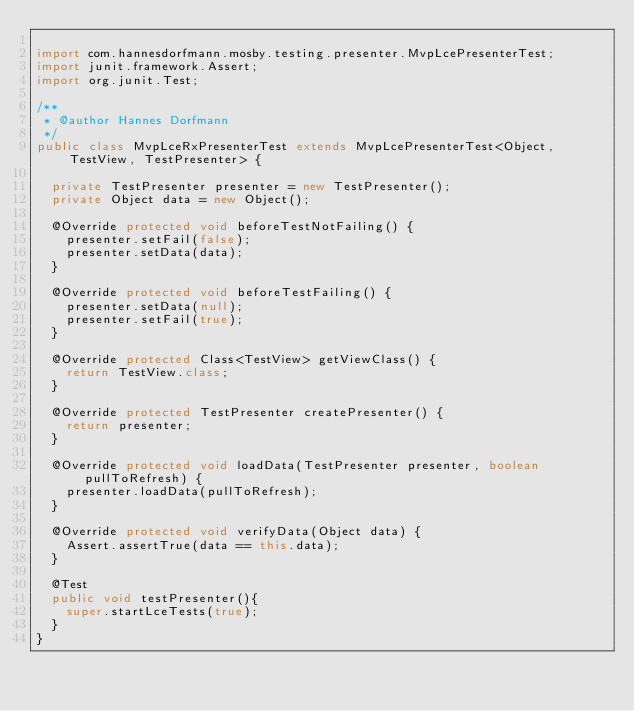<code> <loc_0><loc_0><loc_500><loc_500><_Java_>
import com.hannesdorfmann.mosby.testing.presenter.MvpLcePresenterTest;
import junit.framework.Assert;
import org.junit.Test;

/**
 * @author Hannes Dorfmann
 */
public class MvpLceRxPresenterTest extends MvpLcePresenterTest<Object, TestView, TestPresenter> {

  private TestPresenter presenter = new TestPresenter();
  private Object data = new Object();

  @Override protected void beforeTestNotFailing() {
    presenter.setFail(false);
    presenter.setData(data);
  }

  @Override protected void beforeTestFailing() {
    presenter.setData(null);
    presenter.setFail(true);
  }

  @Override protected Class<TestView> getViewClass() {
    return TestView.class;
  }

  @Override protected TestPresenter createPresenter() {
    return presenter;
  }

  @Override protected void loadData(TestPresenter presenter, boolean pullToRefresh) {
    presenter.loadData(pullToRefresh);
  }

  @Override protected void verifyData(Object data) {
    Assert.assertTrue(data == this.data);
  }

  @Test
  public void testPresenter(){
    super.startLceTests(true);
  }
}
</code> 